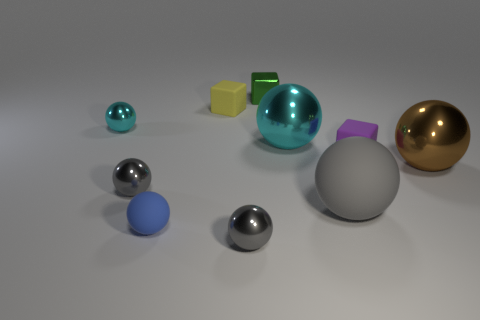Subtract all gray spheres. How many were subtracted if there are1gray spheres left? 2 Subtract all matte blocks. How many blocks are left? 1 Subtract all blue spheres. How many spheres are left? 6 Subtract all red cylinders. How many cyan spheres are left? 2 Subtract 1 cubes. How many cubes are left? 2 Subtract all cubes. How many objects are left? 7 Subtract all tiny red matte balls. Subtract all tiny green metal blocks. How many objects are left? 9 Add 6 purple matte things. How many purple matte things are left? 7 Add 3 shiny cylinders. How many shiny cylinders exist? 3 Subtract 0 blue cylinders. How many objects are left? 10 